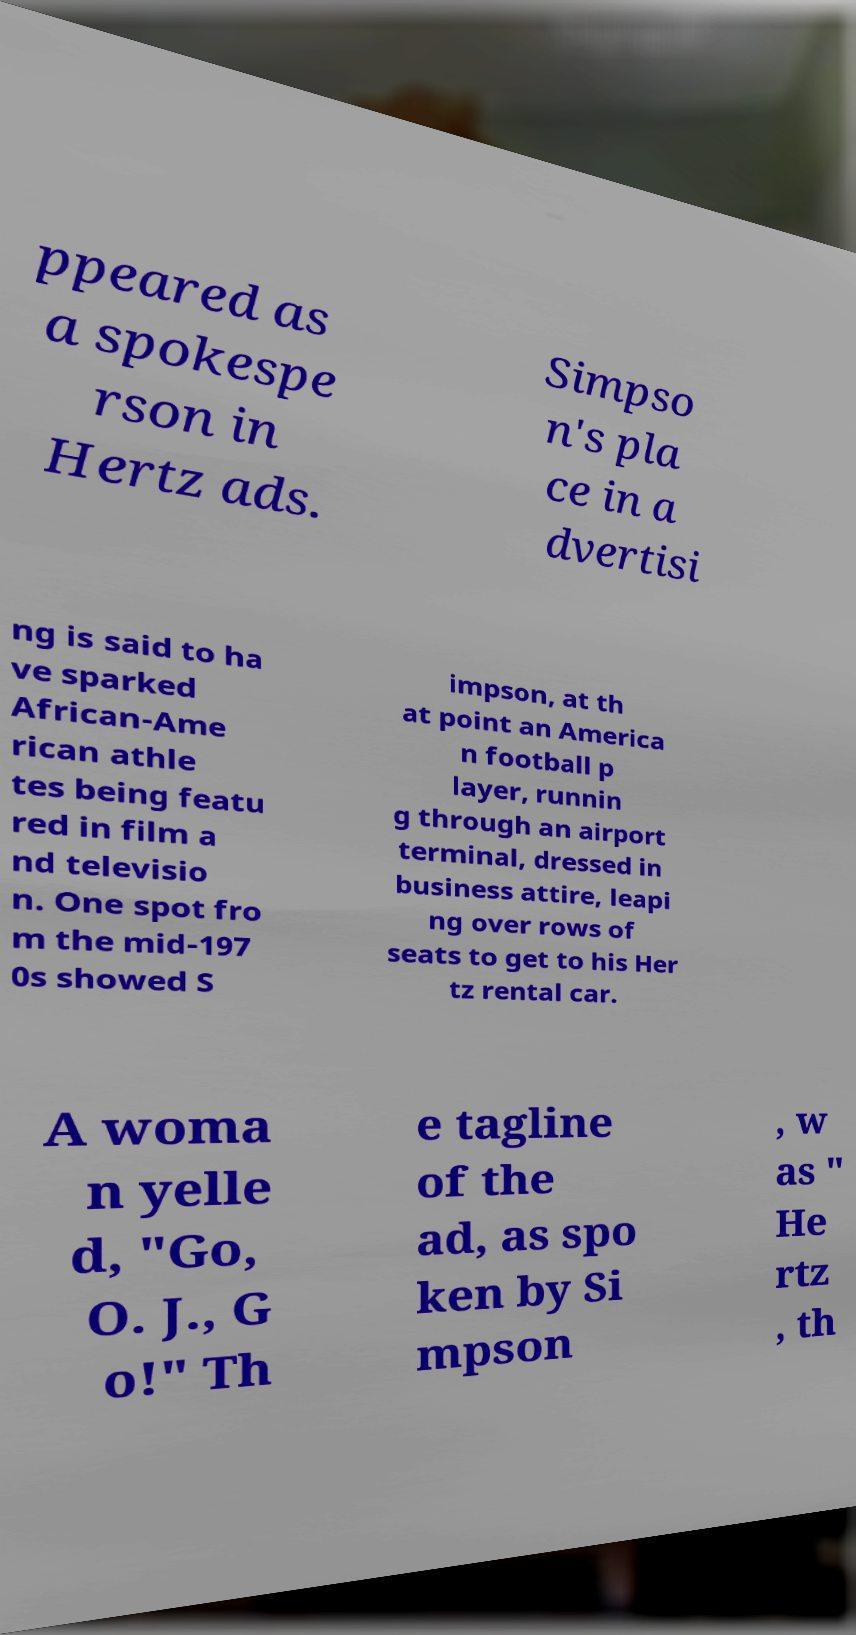Please identify and transcribe the text found in this image. ppeared as a spokespe rson in Hertz ads. Simpso n's pla ce in a dvertisi ng is said to ha ve sparked African-Ame rican athle tes being featu red in film a nd televisio n. One spot fro m the mid-197 0s showed S impson, at th at point an America n football p layer, runnin g through an airport terminal, dressed in business attire, leapi ng over rows of seats to get to his Her tz rental car. A woma n yelle d, "Go, O. J., G o!" Th e tagline of the ad, as spo ken by Si mpson , w as " He rtz , th 